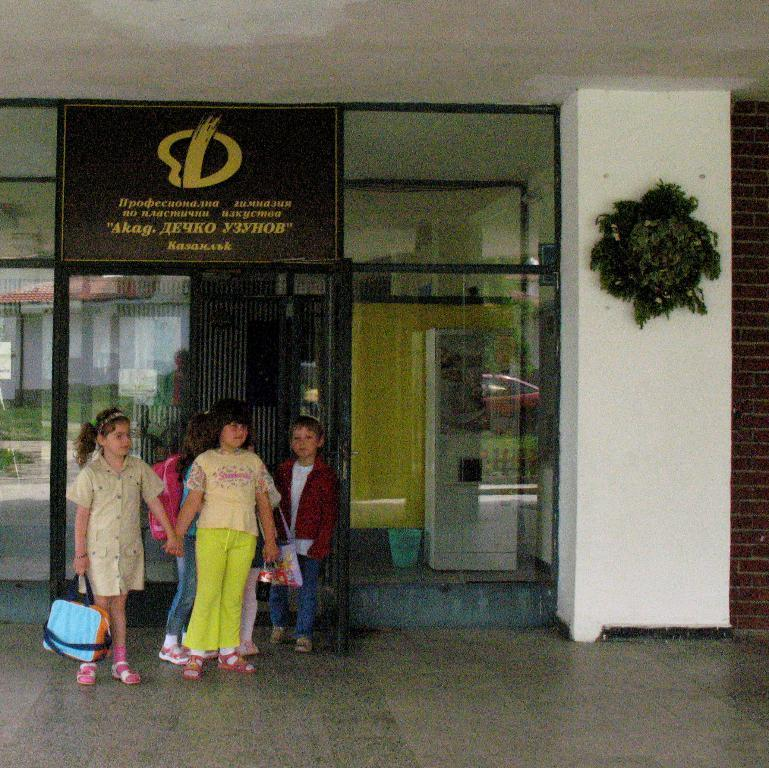What can be seen in the foreground of the image? There are kids standing in the image. What else can be observed in the image besides the kids? There are other objects visible behind the kids. What type of pet can be seen playing with a pickle in the image? There is no pet or pickle present in the image; only the kids and other objects are visible. 